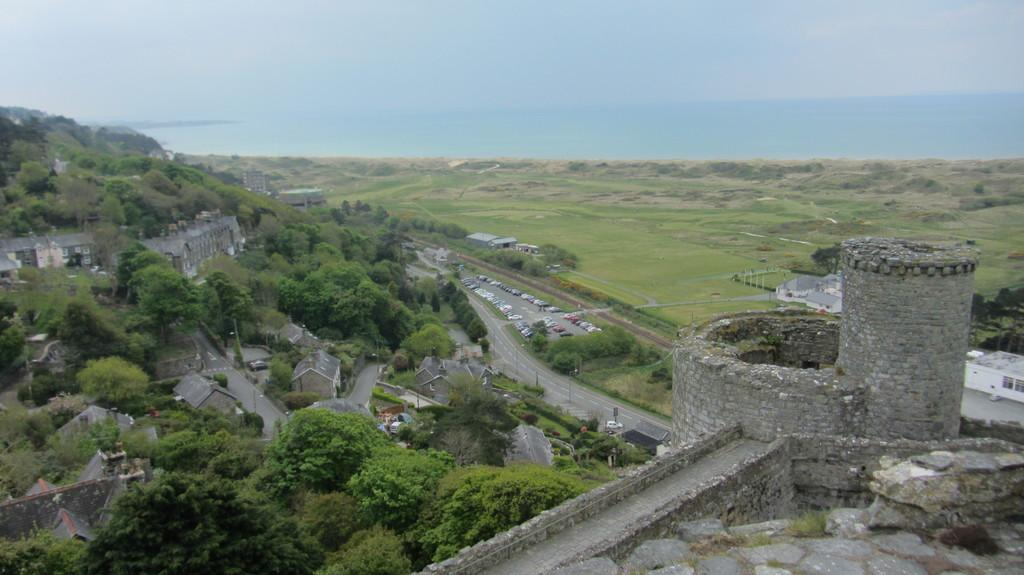What is the main structure visible in the image? There is a fort in the image. What can be seen to the left of the fort? There are roads to the left of the fort. What type of vegetation is present along the roads? Trees and plants are present along the roads. What is visible at the top of the image? The sky is visible at the top of the image. Where is the pickle located in the image? There is no pickle present in the image. What type of glue is being used to hold the pan in the image? There is no pan or glue present in the image. 